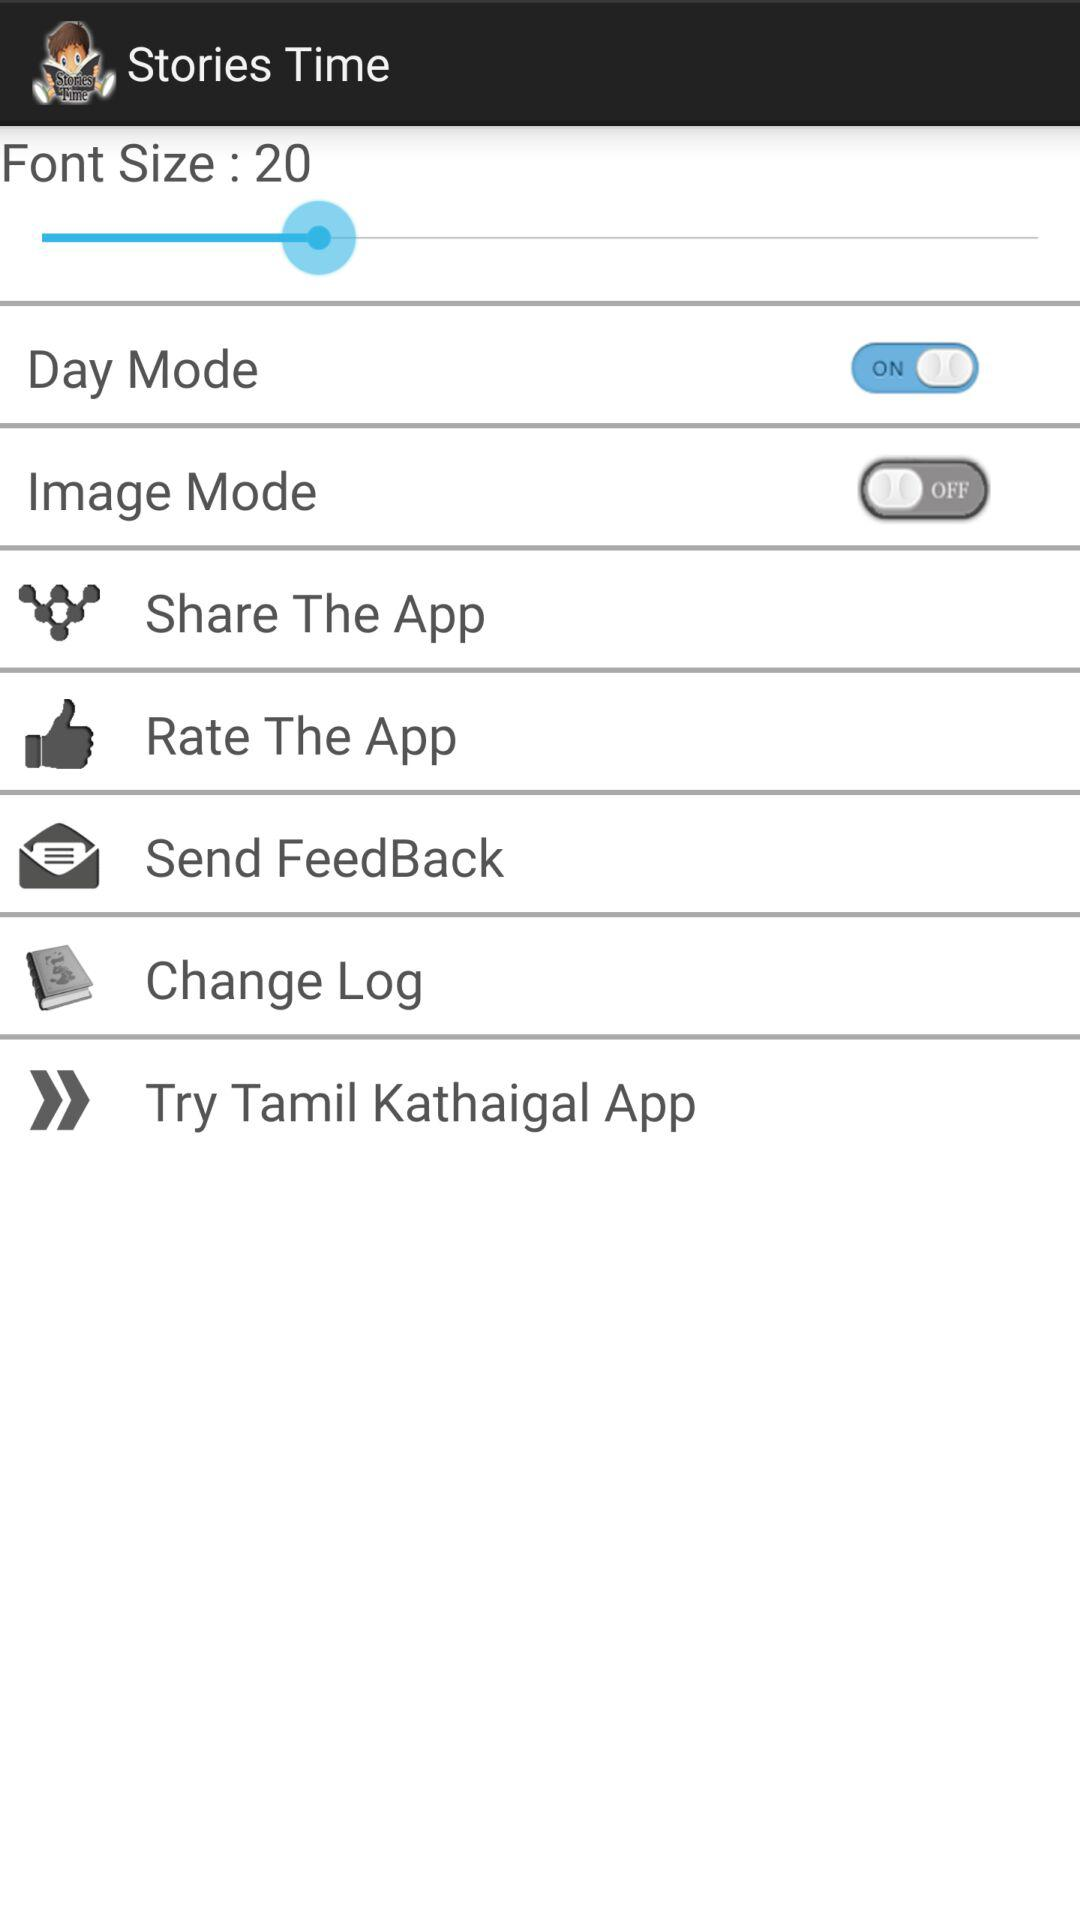What is the name of the application? The name of the application is "Stories Time". 